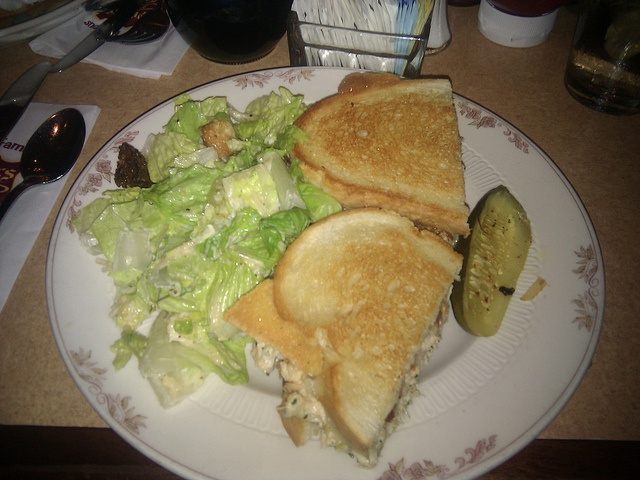Describe the objects in this image and their specific colors. I can see sandwich in black, tan, and olive tones, dining table in black, maroon, and gray tones, cup in black and gray tones, spoon in black, gray, and maroon tones, and knife in black tones in this image. 